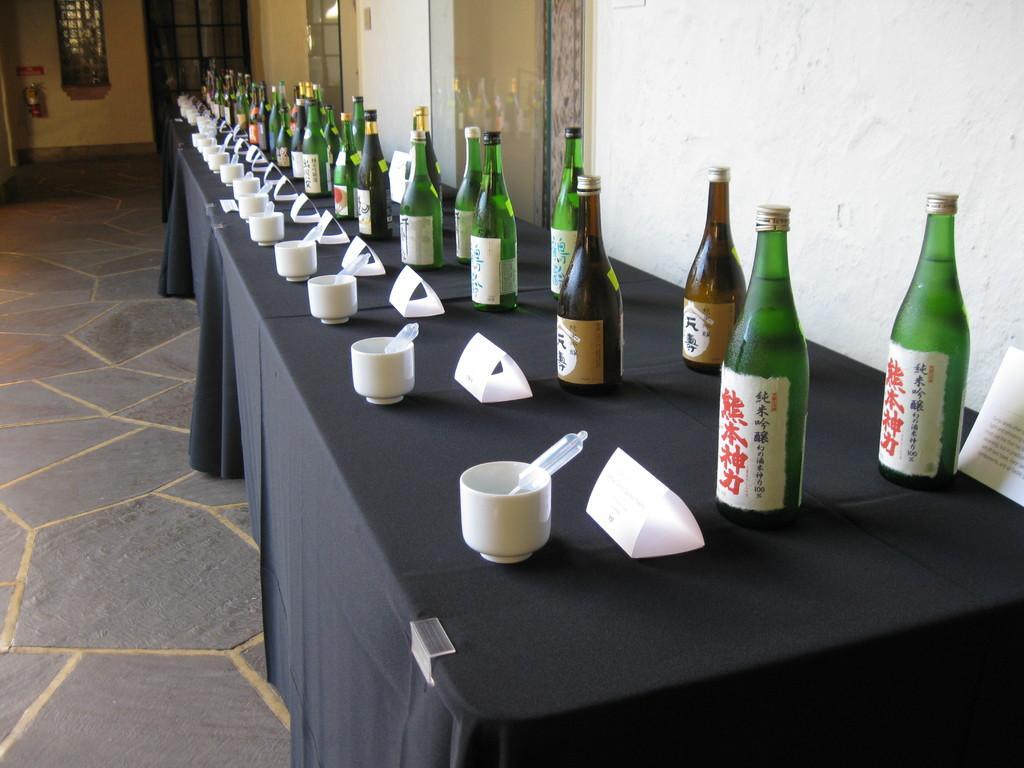Can you describe this image briefly? There is a table which has wine bottles and cups and papers on it. 